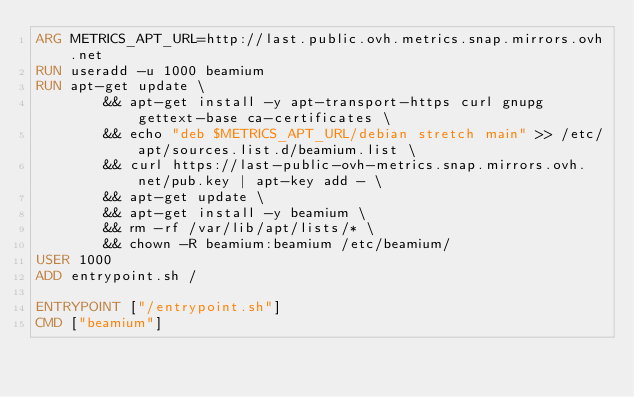<code> <loc_0><loc_0><loc_500><loc_500><_Dockerfile_>ARG METRICS_APT_URL=http://last.public.ovh.metrics.snap.mirrors.ovh.net
RUN useradd -u 1000 beamium
RUN apt-get update \
        && apt-get install -y apt-transport-https curl gnupg gettext-base ca-certificates \
        && echo "deb $METRICS_APT_URL/debian stretch main" >> /etc/apt/sources.list.d/beamium.list \
        && curl https://last-public-ovh-metrics.snap.mirrors.ovh.net/pub.key | apt-key add - \
        && apt-get update \
        && apt-get install -y beamium \
        && rm -rf /var/lib/apt/lists/* \
        && chown -R beamium:beamium /etc/beamium/
USER 1000
ADD entrypoint.sh /

ENTRYPOINT ["/entrypoint.sh"]
CMD ["beamium"]
</code> 